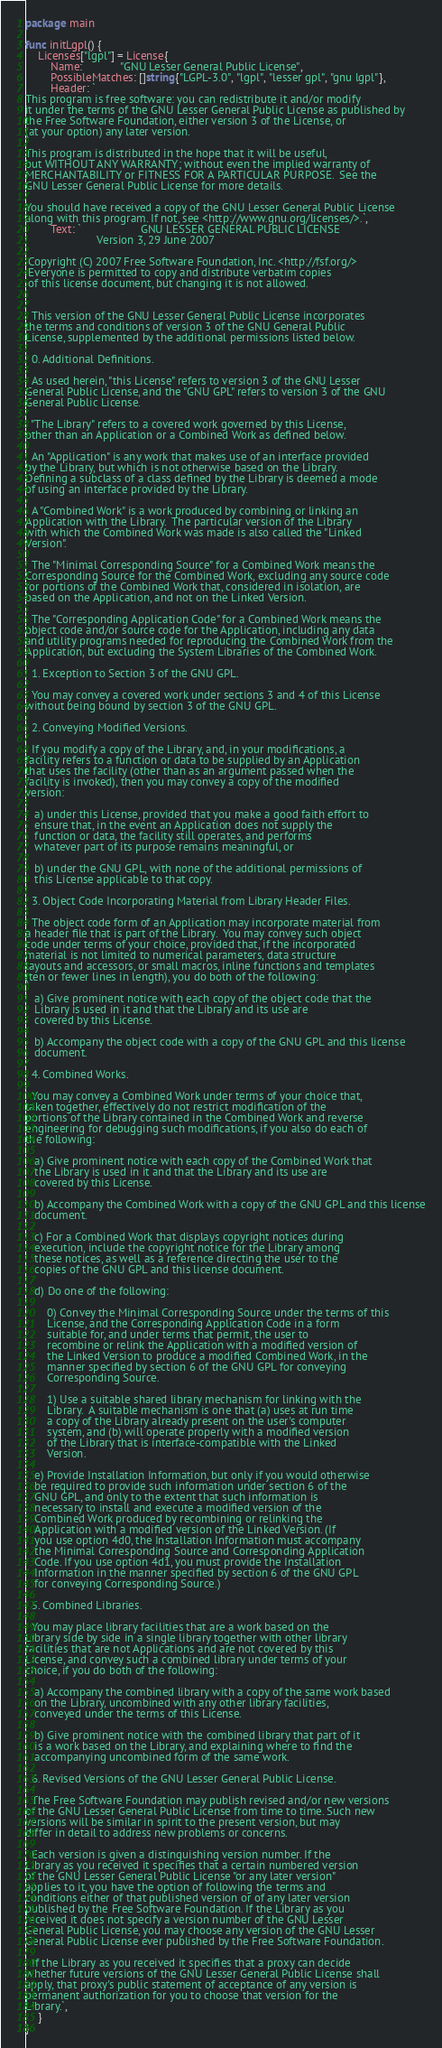<code> <loc_0><loc_0><loc_500><loc_500><_Go_>package main

func initLgpl() {
	Licenses["lgpl"] = License{
		Name:            "GNU Lesser General Public License",
		PossibleMatches: []string{"LGPL-3.0", "lgpl", "lesser gpl", "gnu lgpl"},
		Header: `
This program is free software: you can redistribute it and/or modify
it under the terms of the GNU Lesser General Public License as published by
the Free Software Foundation, either version 3 of the License, or
(at your option) any later version.

This program is distributed in the hope that it will be useful,
but WITHOUT ANY WARRANTY; without even the implied warranty of
MERCHANTABILITY or FITNESS FOR A PARTICULAR PURPOSE.  See the
GNU Lesser General Public License for more details.

You should have received a copy of the GNU Lesser General Public License
along with this program. If not, see <http://www.gnu.org/licenses/>.`,
		Text: `                   GNU LESSER GENERAL PUBLIC LICENSE
                       Version 3, 29 June 2007

 Copyright (C) 2007 Free Software Foundation, Inc. <http://fsf.org/>
 Everyone is permitted to copy and distribute verbatim copies
 of this license document, but changing it is not allowed.


  This version of the GNU Lesser General Public License incorporates
the terms and conditions of version 3 of the GNU General Public
License, supplemented by the additional permissions listed below.

  0. Additional Definitions.

  As used herein, "this License" refers to version 3 of the GNU Lesser
General Public License, and the "GNU GPL" refers to version 3 of the GNU
General Public License.

  "The Library" refers to a covered work governed by this License,
other than an Application or a Combined Work as defined below.

  An "Application" is any work that makes use of an interface provided
by the Library, but which is not otherwise based on the Library.
Defining a subclass of a class defined by the Library is deemed a mode
of using an interface provided by the Library.

  A "Combined Work" is a work produced by combining or linking an
Application with the Library.  The particular version of the Library
with which the Combined Work was made is also called the "Linked
Version".

  The "Minimal Corresponding Source" for a Combined Work means the
Corresponding Source for the Combined Work, excluding any source code
for portions of the Combined Work that, considered in isolation, are
based on the Application, and not on the Linked Version.

  The "Corresponding Application Code" for a Combined Work means the
object code and/or source code for the Application, including any data
and utility programs needed for reproducing the Combined Work from the
Application, but excluding the System Libraries of the Combined Work.

  1. Exception to Section 3 of the GNU GPL.

  You may convey a covered work under sections 3 and 4 of this License
without being bound by section 3 of the GNU GPL.

  2. Conveying Modified Versions.

  If you modify a copy of the Library, and, in your modifications, a
facility refers to a function or data to be supplied by an Application
that uses the facility (other than as an argument passed when the
facility is invoked), then you may convey a copy of the modified
version:

   a) under this License, provided that you make a good faith effort to
   ensure that, in the event an Application does not supply the
   function or data, the facility still operates, and performs
   whatever part of its purpose remains meaningful, or

   b) under the GNU GPL, with none of the additional permissions of
   this License applicable to that copy.

  3. Object Code Incorporating Material from Library Header Files.

  The object code form of an Application may incorporate material from
a header file that is part of the Library.  You may convey such object
code under terms of your choice, provided that, if the incorporated
material is not limited to numerical parameters, data structure
layouts and accessors, or small macros, inline functions and templates
(ten or fewer lines in length), you do both of the following:

   a) Give prominent notice with each copy of the object code that the
   Library is used in it and that the Library and its use are
   covered by this License.

   b) Accompany the object code with a copy of the GNU GPL and this license
   document.

  4. Combined Works.

  You may convey a Combined Work under terms of your choice that,
taken together, effectively do not restrict modification of the
portions of the Library contained in the Combined Work and reverse
engineering for debugging such modifications, if you also do each of
the following:

   a) Give prominent notice with each copy of the Combined Work that
   the Library is used in it and that the Library and its use are
   covered by this License.

   b) Accompany the Combined Work with a copy of the GNU GPL and this license
   document.

   c) For a Combined Work that displays copyright notices during
   execution, include the copyright notice for the Library among
   these notices, as well as a reference directing the user to the
   copies of the GNU GPL and this license document.

   d) Do one of the following:

       0) Convey the Minimal Corresponding Source under the terms of this
       License, and the Corresponding Application Code in a form
       suitable for, and under terms that permit, the user to
       recombine or relink the Application with a modified version of
       the Linked Version to produce a modified Combined Work, in the
       manner specified by section 6 of the GNU GPL for conveying
       Corresponding Source.

       1) Use a suitable shared library mechanism for linking with the
       Library.  A suitable mechanism is one that (a) uses at run time
       a copy of the Library already present on the user's computer
       system, and (b) will operate properly with a modified version
       of the Library that is interface-compatible with the Linked
       Version.

   e) Provide Installation Information, but only if you would otherwise
   be required to provide such information under section 6 of the
   GNU GPL, and only to the extent that such information is
   necessary to install and execute a modified version of the
   Combined Work produced by recombining or relinking the
   Application with a modified version of the Linked Version. (If
   you use option 4d0, the Installation Information must accompany
   the Minimal Corresponding Source and Corresponding Application
   Code. If you use option 4d1, you must provide the Installation
   Information in the manner specified by section 6 of the GNU GPL
   for conveying Corresponding Source.)

  5. Combined Libraries.

  You may place library facilities that are a work based on the
Library side by side in a single library together with other library
facilities that are not Applications and are not covered by this
License, and convey such a combined library under terms of your
choice, if you do both of the following:

   a) Accompany the combined library with a copy of the same work based
   on the Library, uncombined with any other library facilities,
   conveyed under the terms of this License.

   b) Give prominent notice with the combined library that part of it
   is a work based on the Library, and explaining where to find the
   accompanying uncombined form of the same work.

  6. Revised Versions of the GNU Lesser General Public License.

  The Free Software Foundation may publish revised and/or new versions
of the GNU Lesser General Public License from time to time. Such new
versions will be similar in spirit to the present version, but may
differ in detail to address new problems or concerns.

  Each version is given a distinguishing version number. If the
Library as you received it specifies that a certain numbered version
of the GNU Lesser General Public License "or any later version"
applies to it, you have the option of following the terms and
conditions either of that published version or of any later version
published by the Free Software Foundation. If the Library as you
received it does not specify a version number of the GNU Lesser
General Public License, you may choose any version of the GNU Lesser
General Public License ever published by the Free Software Foundation.

  If the Library as you received it specifies that a proxy can decide
whether future versions of the GNU Lesser General Public License shall
apply, that proxy's public statement of acceptance of any version is
permanent authorization for you to choose that version for the
Library.`,
	}
}
</code> 